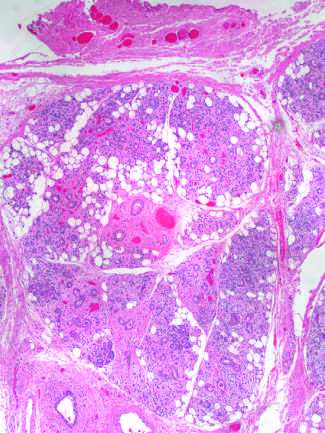what is vascular changes and fibrosis of salivary glands produced by?
Answer the question using a single word or phrase. Radiation therapy of the neck region 